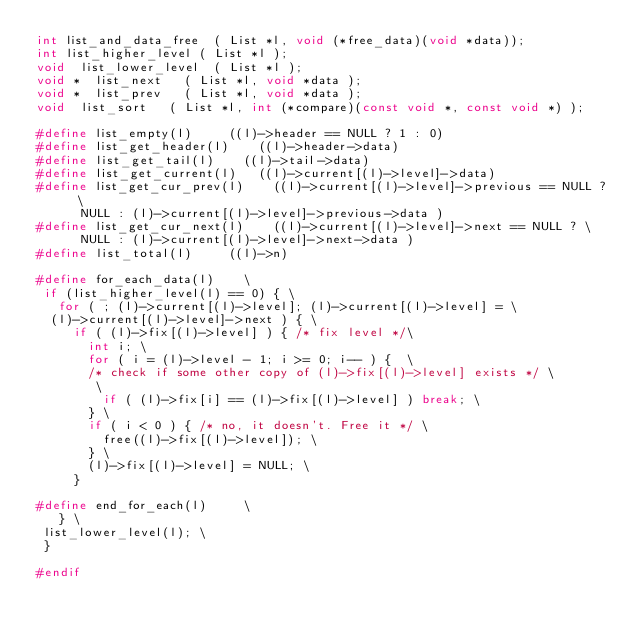<code> <loc_0><loc_0><loc_500><loc_500><_C_>int	list_and_data_free	( List *l, void (*free_data)(void *data));
int	list_higher_level	( List *l );
void	list_lower_level	( List *l );
void *	list_next		( List *l, void *data );
void *	list_prev		( List *l, void *data );
void	list_sort		( List *l, int (*compare)(const void *, const void *) );

#define list_empty(l)			((l)->header == NULL ? 1 : 0)
#define list_get_header(l)		((l)->header->data)
#define list_get_tail(l)		((l)->tail->data)
#define list_get_current(l)		((l)->current[(l)->level]->data)
#define list_get_cur_prev(l)		((l)->current[(l)->level]->previous == NULL ? \
			NULL : (l)->current[(l)->level]->previous->data )
#define list_get_cur_next(l)		((l)->current[(l)->level]->next == NULL ? \
			NULL : (l)->current[(l)->level]->next->data )
#define list_total(l)			((l)->n)

#define for_each_data(l)		\
 if (list_higher_level(l) == 0) { \
   for ( ; (l)->current[(l)->level]; (l)->current[(l)->level] = \
	(l)->current[(l)->level]->next ) { \
     if ( (l)->fix[(l)->level] ) { /* fix level */\
       int i; \
       for ( i = (l)->level - 1; i >= 0; i-- ) {  \
       /* check if some other copy of (l)->fix[(l)->level] exists */ \
        \
         if ( (l)->fix[i] == (l)->fix[(l)->level] ) break; \
       } \
       if ( i < 0 ) { /* no, it doesn't. Free it */ \
         free((l)->fix[(l)->level]); \
       } \
       (l)->fix[(l)->level] = NULL; \
     }

#define end_for_each(l)			\
   } \
 list_lower_level(l); \
 }

#endif
</code> 